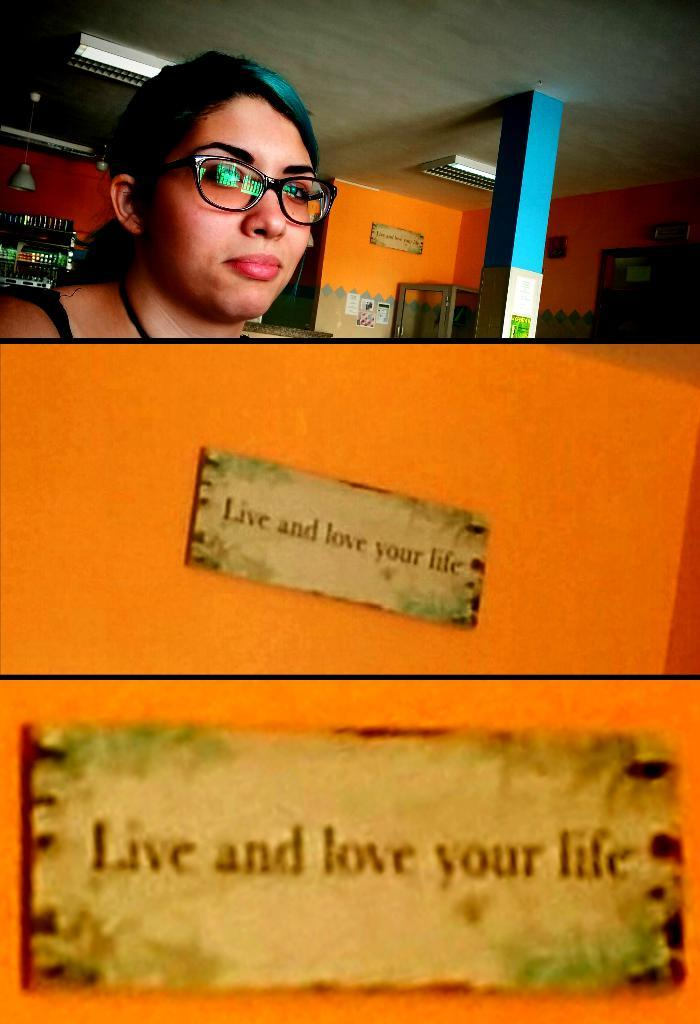What is present on the wall in the image? There are two boards on the wall in the image. Can you describe the person behind the wall? There is a person behind the wall, but their appearance or actions are not visible in the image. What else can be seen in the background of the image? There is another person in the background. What is above the wall in the image? There is a roof with lights in the image. How many times does the person in the background sneeze in the image? There is no indication of the person in the background sneezing in the image. What color does the person's body change to in the image? There is no indication of the person's body changing color in the image. 